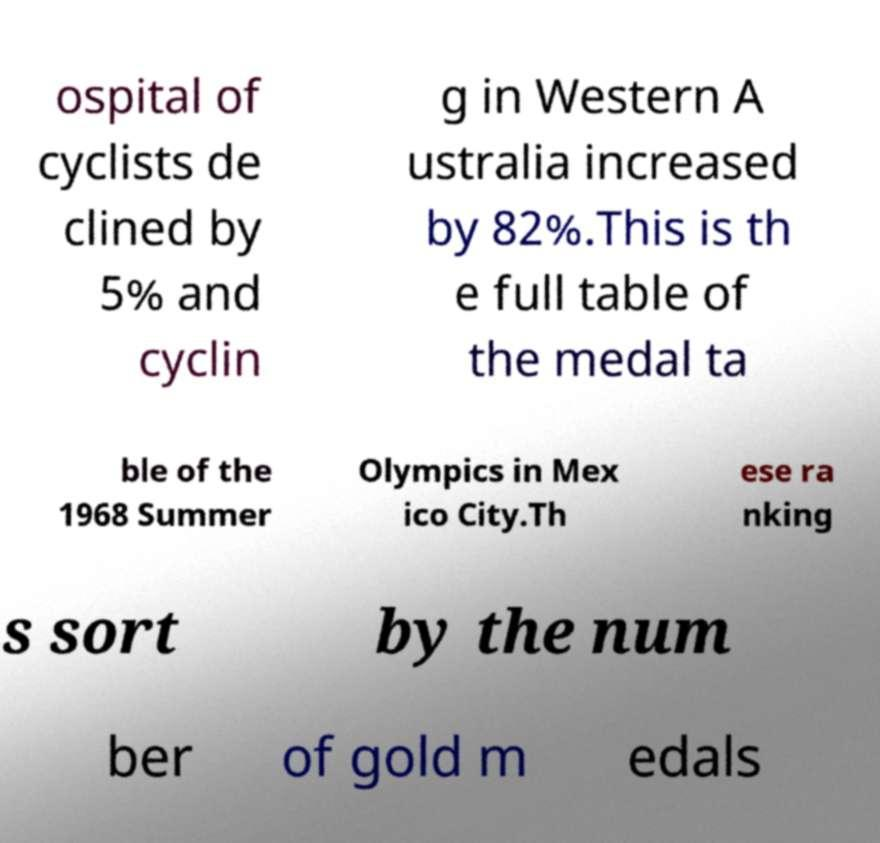Could you extract and type out the text from this image? ospital of cyclists de clined by 5% and cyclin g in Western A ustralia increased by 82%.This is th e full table of the medal ta ble of the 1968 Summer Olympics in Mex ico City.Th ese ra nking s sort by the num ber of gold m edals 